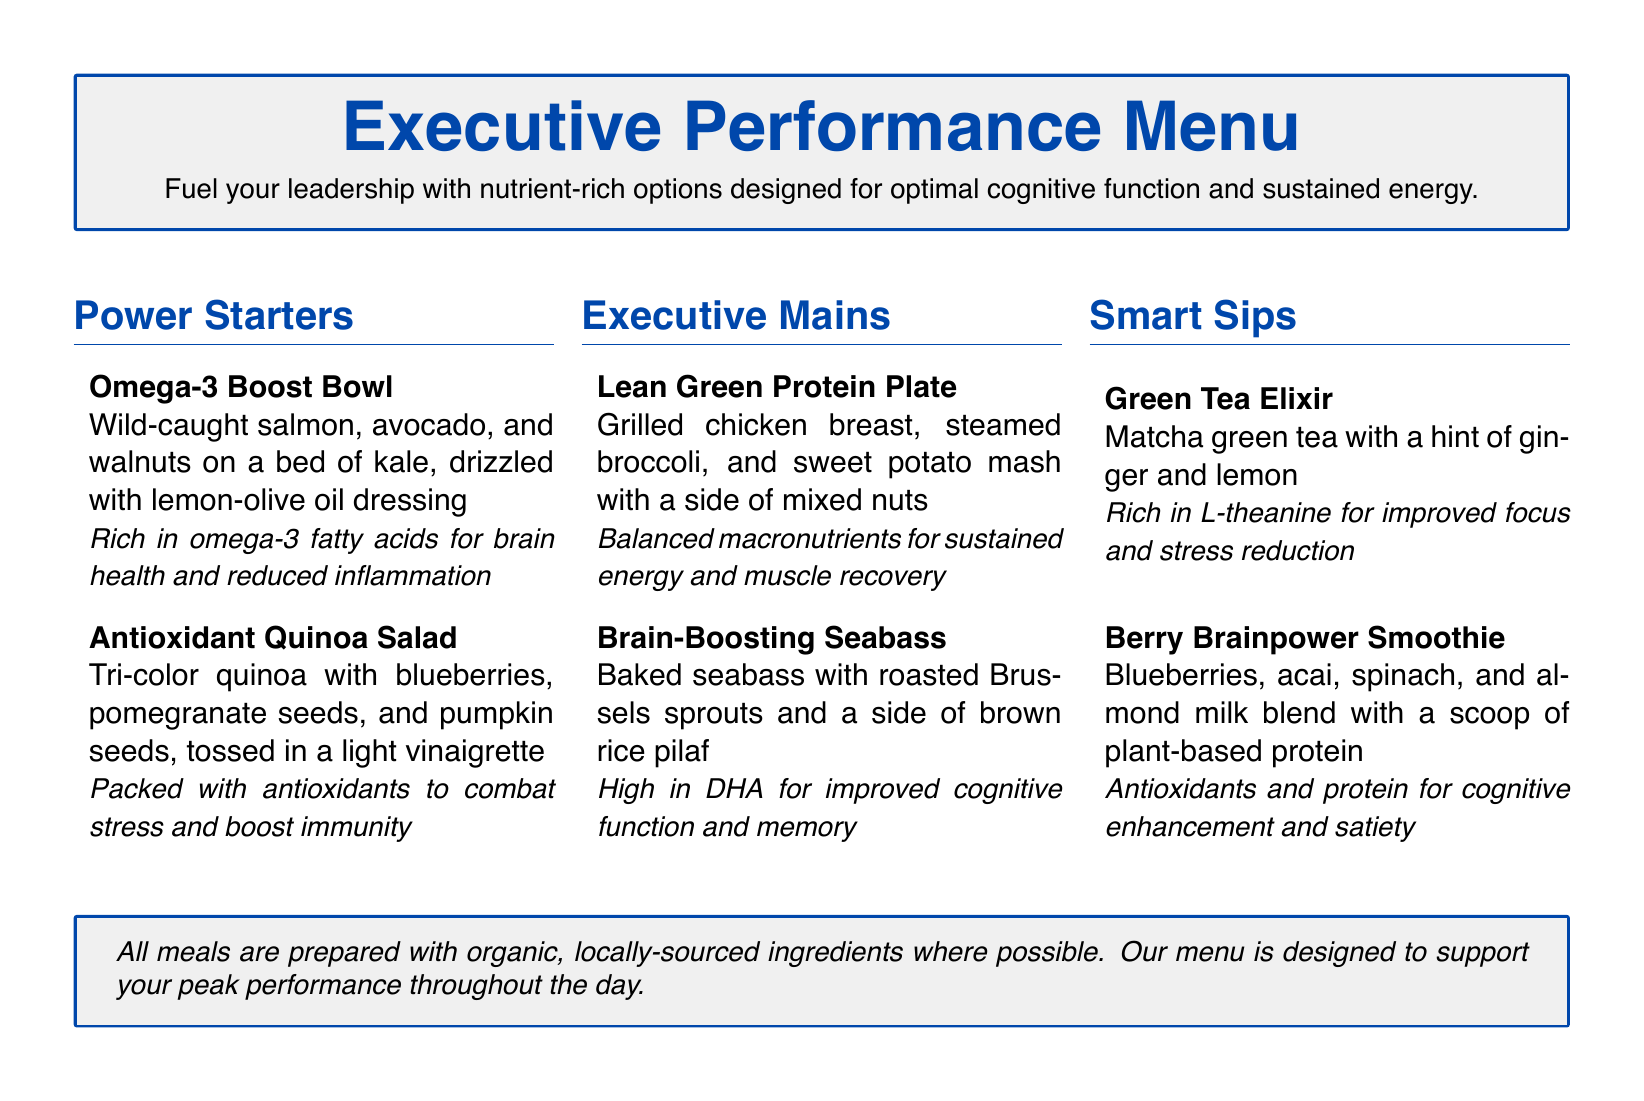What is the title of the menu? The title of the menu is indicated at the beginning and is "Executive Performance Menu."
Answer: Executive Performance Menu How many Power Starters are on the menu? The menu lists two options under the Power Starters section.
Answer: 2 What is included in the Lean Green Protein Plate? The Lean Green Protein Plate consists of grilled chicken breast, steamed broccoli, and sweet potato mash with a side of mixed nuts.
Answer: Grilled chicken breast, steamed broccoli, sweet potato mash, mixed nuts Which dish is mentioned as high in DHA? The menu specifies that the Brain-Boosting Seabass is high in DHA for improved cognitive function and memory.
Answer: Brain-Boosting Seabass What is the primary health benefit of the Omega-3 Boost Bowl? The Omega-3 Boost Bowl is rich in omega-3 fatty acids for brain health and reduced inflammation.
Answer: Brain health and reduced inflammation What type of beverage is the Berry Brainpower Smoothie? The Berry Brainpower Smoothie is classified under the Smart Sips section of the menu.
Answer: Smoothie What main ingredient is used in the Green Tea Elixir? The main ingredient in the Green Tea Elixir is matcha green tea.
Answer: Matcha green tea Which section follows the Power Starters on the menu? The section that follows Power Starters is the Executive Mains.
Answer: Executive Mains 